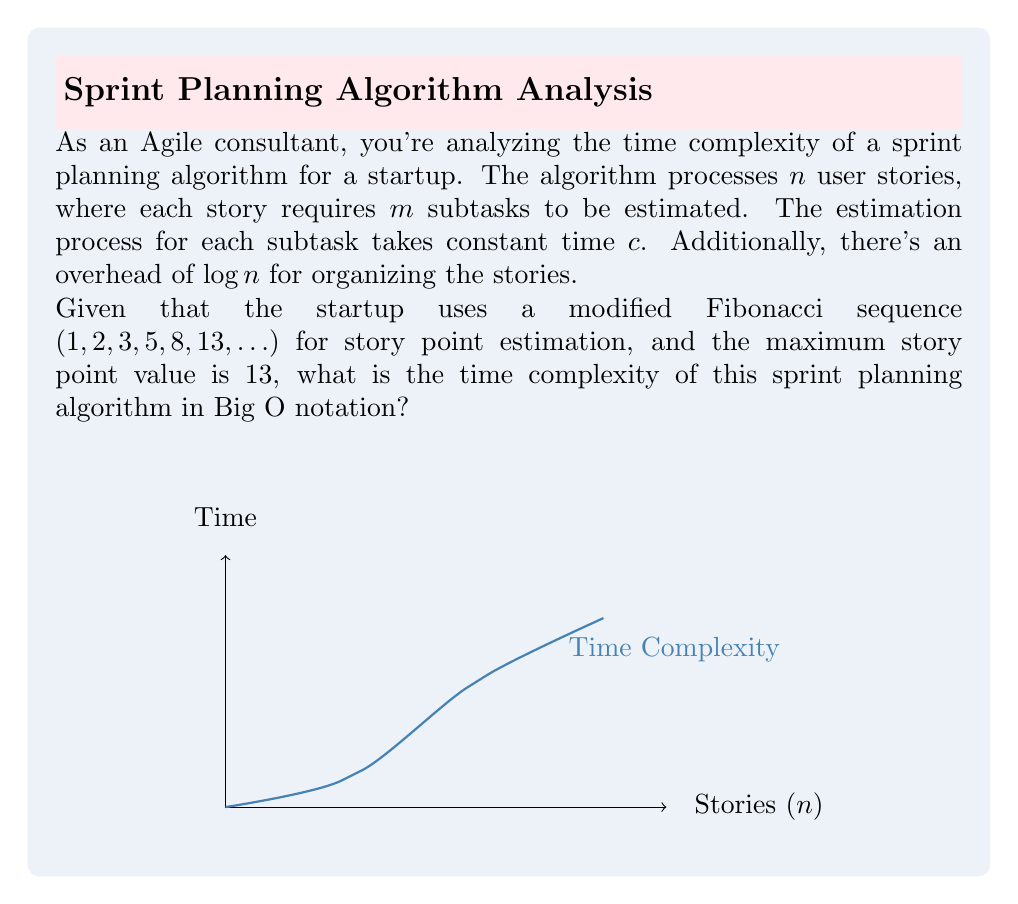Could you help me with this problem? Let's break down the problem and analyze the time complexity step by step:

1) For each user story, we need to estimate $m$ subtasks.
   Time for one story: $O(m)$

2) The estimation of each subtask takes constant time $c$.
   This doesn't affect the Big O notation, so we can ignore it.

3) We have $n$ user stories in total.
   Total time for all stories: $O(n \cdot m)$

4) There's an additional overhead of $\log n$ for organizing the stories.
   Overhead time: $O(\log n)$

5) The total time complexity is the sum of processing all stories and the overhead:
   $T(n) = O(n \cdot m + \log n)$

6) The modified Fibonacci sequence for story points is bounded by a maximum value of 13.
   This means that $m$ (the number of subtasks) is effectively constant and doesn't grow with $n$.

7) In Big O notation, we can treat $m$ as a constant factor:
   $T(n) = O(n \cdot constant + \log n) = O(n + \log n)$

8) In Big O notation, we keep only the fastest-growing term:
   $O(n + \log n) = O(n)$, since $n$ grows faster than $\log n$

Therefore, the time complexity of this sprint planning algorithm is $O(n)$.
Answer: $O(n)$ 